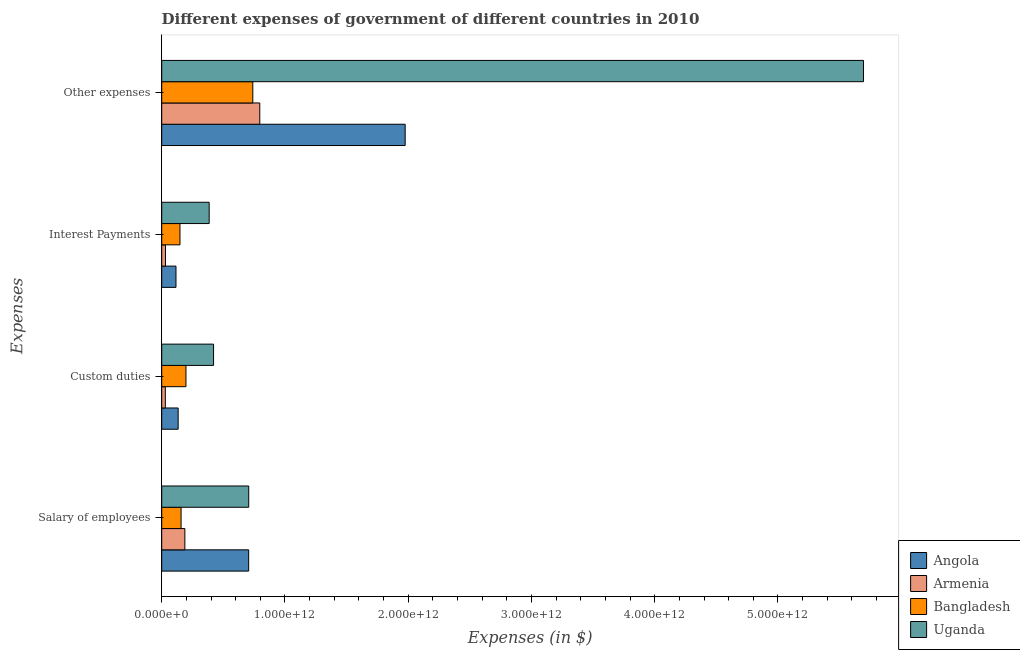How many different coloured bars are there?
Offer a terse response. 4. Are the number of bars on each tick of the Y-axis equal?
Your response must be concise. Yes. How many bars are there on the 3rd tick from the top?
Your answer should be compact. 4. How many bars are there on the 1st tick from the bottom?
Offer a very short reply. 4. What is the label of the 1st group of bars from the top?
Provide a short and direct response. Other expenses. What is the amount spent on custom duties in Angola?
Make the answer very short. 1.33e+11. Across all countries, what is the maximum amount spent on salary of employees?
Provide a short and direct response. 7.06e+11. Across all countries, what is the minimum amount spent on custom duties?
Your response must be concise. 2.94e+1. In which country was the amount spent on custom duties maximum?
Give a very brief answer. Uganda. In which country was the amount spent on custom duties minimum?
Ensure brevity in your answer.  Armenia. What is the total amount spent on other expenses in the graph?
Your answer should be compact. 9.20e+12. What is the difference between the amount spent on salary of employees in Angola and that in Uganda?
Your answer should be compact. -5.06e+08. What is the difference between the amount spent on salary of employees in Angola and the amount spent on other expenses in Bangladesh?
Provide a succinct answer. -3.34e+1. What is the average amount spent on salary of employees per country?
Keep it short and to the point. 4.39e+11. What is the difference between the amount spent on custom duties and amount spent on other expenses in Uganda?
Offer a terse response. -5.27e+12. What is the ratio of the amount spent on salary of employees in Bangladesh to that in Armenia?
Give a very brief answer. 0.84. Is the difference between the amount spent on interest payments in Bangladesh and Angola greater than the difference between the amount spent on custom duties in Bangladesh and Angola?
Provide a short and direct response. No. What is the difference between the highest and the second highest amount spent on custom duties?
Provide a short and direct response. 2.24e+11. What is the difference between the highest and the lowest amount spent on custom duties?
Offer a terse response. 3.91e+11. In how many countries, is the amount spent on custom duties greater than the average amount spent on custom duties taken over all countries?
Your answer should be very brief. 2. Is it the case that in every country, the sum of the amount spent on other expenses and amount spent on salary of employees is greater than the sum of amount spent on custom duties and amount spent on interest payments?
Provide a short and direct response. Yes. What does the 3rd bar from the top in Other expenses represents?
Offer a terse response. Armenia. What does the 4th bar from the bottom in Custom duties represents?
Provide a short and direct response. Uganda. Are all the bars in the graph horizontal?
Your answer should be compact. Yes. How many countries are there in the graph?
Provide a succinct answer. 4. What is the difference between two consecutive major ticks on the X-axis?
Offer a very short reply. 1.00e+12. Are the values on the major ticks of X-axis written in scientific E-notation?
Offer a terse response. Yes. Does the graph contain grids?
Your response must be concise. No. Where does the legend appear in the graph?
Your answer should be very brief. Bottom right. How are the legend labels stacked?
Provide a short and direct response. Vertical. What is the title of the graph?
Offer a terse response. Different expenses of government of different countries in 2010. What is the label or title of the X-axis?
Your answer should be very brief. Expenses (in $). What is the label or title of the Y-axis?
Provide a short and direct response. Expenses. What is the Expenses (in $) in Angola in Salary of employees?
Your answer should be compact. 7.06e+11. What is the Expenses (in $) in Armenia in Salary of employees?
Offer a very short reply. 1.88e+11. What is the Expenses (in $) in Bangladesh in Salary of employees?
Keep it short and to the point. 1.57e+11. What is the Expenses (in $) in Uganda in Salary of employees?
Keep it short and to the point. 7.06e+11. What is the Expenses (in $) in Angola in Custom duties?
Give a very brief answer. 1.33e+11. What is the Expenses (in $) of Armenia in Custom duties?
Your answer should be very brief. 2.94e+1. What is the Expenses (in $) in Bangladesh in Custom duties?
Keep it short and to the point. 1.97e+11. What is the Expenses (in $) in Uganda in Custom duties?
Your response must be concise. 4.21e+11. What is the Expenses (in $) in Angola in Interest Payments?
Ensure brevity in your answer.  1.16e+11. What is the Expenses (in $) in Armenia in Interest Payments?
Offer a very short reply. 3.04e+1. What is the Expenses (in $) of Bangladesh in Interest Payments?
Provide a short and direct response. 1.48e+11. What is the Expenses (in $) of Uganda in Interest Payments?
Your answer should be very brief. 3.85e+11. What is the Expenses (in $) in Angola in Other expenses?
Ensure brevity in your answer.  1.98e+12. What is the Expenses (in $) in Armenia in Other expenses?
Make the answer very short. 7.96e+11. What is the Expenses (in $) of Bangladesh in Other expenses?
Your response must be concise. 7.39e+11. What is the Expenses (in $) in Uganda in Other expenses?
Offer a terse response. 5.69e+12. Across all Expenses, what is the maximum Expenses (in $) of Angola?
Offer a terse response. 1.98e+12. Across all Expenses, what is the maximum Expenses (in $) in Armenia?
Provide a succinct answer. 7.96e+11. Across all Expenses, what is the maximum Expenses (in $) in Bangladesh?
Provide a succinct answer. 7.39e+11. Across all Expenses, what is the maximum Expenses (in $) of Uganda?
Offer a very short reply. 5.69e+12. Across all Expenses, what is the minimum Expenses (in $) of Angola?
Provide a short and direct response. 1.16e+11. Across all Expenses, what is the minimum Expenses (in $) in Armenia?
Provide a succinct answer. 2.94e+1. Across all Expenses, what is the minimum Expenses (in $) in Bangladesh?
Offer a very short reply. 1.48e+11. Across all Expenses, what is the minimum Expenses (in $) in Uganda?
Your answer should be very brief. 3.85e+11. What is the total Expenses (in $) of Angola in the graph?
Give a very brief answer. 2.93e+12. What is the total Expenses (in $) in Armenia in the graph?
Offer a terse response. 1.04e+12. What is the total Expenses (in $) in Bangladesh in the graph?
Give a very brief answer. 1.24e+12. What is the total Expenses (in $) of Uganda in the graph?
Offer a terse response. 7.21e+12. What is the difference between the Expenses (in $) of Angola in Salary of employees and that in Custom duties?
Provide a succinct answer. 5.72e+11. What is the difference between the Expenses (in $) in Armenia in Salary of employees and that in Custom duties?
Offer a terse response. 1.58e+11. What is the difference between the Expenses (in $) in Bangladesh in Salary of employees and that in Custom duties?
Keep it short and to the point. -3.95e+1. What is the difference between the Expenses (in $) in Uganda in Salary of employees and that in Custom duties?
Offer a very short reply. 2.85e+11. What is the difference between the Expenses (in $) in Angola in Salary of employees and that in Interest Payments?
Offer a very short reply. 5.90e+11. What is the difference between the Expenses (in $) in Armenia in Salary of employees and that in Interest Payments?
Make the answer very short. 1.57e+11. What is the difference between the Expenses (in $) in Bangladesh in Salary of employees and that in Interest Payments?
Give a very brief answer. 8.98e+09. What is the difference between the Expenses (in $) in Uganda in Salary of employees and that in Interest Payments?
Provide a succinct answer. 3.21e+11. What is the difference between the Expenses (in $) of Angola in Salary of employees and that in Other expenses?
Your response must be concise. -1.27e+12. What is the difference between the Expenses (in $) in Armenia in Salary of employees and that in Other expenses?
Ensure brevity in your answer.  -6.08e+11. What is the difference between the Expenses (in $) of Bangladesh in Salary of employees and that in Other expenses?
Ensure brevity in your answer.  -5.82e+11. What is the difference between the Expenses (in $) of Uganda in Salary of employees and that in Other expenses?
Provide a short and direct response. -4.99e+12. What is the difference between the Expenses (in $) of Angola in Custom duties and that in Interest Payments?
Offer a very short reply. 1.76e+1. What is the difference between the Expenses (in $) of Armenia in Custom duties and that in Interest Payments?
Give a very brief answer. -1.07e+09. What is the difference between the Expenses (in $) of Bangladesh in Custom duties and that in Interest Payments?
Provide a succinct answer. 4.85e+1. What is the difference between the Expenses (in $) of Uganda in Custom duties and that in Interest Payments?
Your response must be concise. 3.56e+1. What is the difference between the Expenses (in $) in Angola in Custom duties and that in Other expenses?
Make the answer very short. -1.84e+12. What is the difference between the Expenses (in $) in Armenia in Custom duties and that in Other expenses?
Ensure brevity in your answer.  -7.66e+11. What is the difference between the Expenses (in $) of Bangladesh in Custom duties and that in Other expenses?
Make the answer very short. -5.42e+11. What is the difference between the Expenses (in $) in Uganda in Custom duties and that in Other expenses?
Ensure brevity in your answer.  -5.27e+12. What is the difference between the Expenses (in $) of Angola in Interest Payments and that in Other expenses?
Provide a short and direct response. -1.86e+12. What is the difference between the Expenses (in $) of Armenia in Interest Payments and that in Other expenses?
Your answer should be very brief. -7.65e+11. What is the difference between the Expenses (in $) in Bangladesh in Interest Payments and that in Other expenses?
Offer a terse response. -5.91e+11. What is the difference between the Expenses (in $) of Uganda in Interest Payments and that in Other expenses?
Your answer should be compact. -5.31e+12. What is the difference between the Expenses (in $) of Angola in Salary of employees and the Expenses (in $) of Armenia in Custom duties?
Your response must be concise. 6.76e+11. What is the difference between the Expenses (in $) in Angola in Salary of employees and the Expenses (in $) in Bangladesh in Custom duties?
Offer a terse response. 5.09e+11. What is the difference between the Expenses (in $) in Angola in Salary of employees and the Expenses (in $) in Uganda in Custom duties?
Make the answer very short. 2.85e+11. What is the difference between the Expenses (in $) in Armenia in Salary of employees and the Expenses (in $) in Bangladesh in Custom duties?
Keep it short and to the point. -8.88e+09. What is the difference between the Expenses (in $) in Armenia in Salary of employees and the Expenses (in $) in Uganda in Custom duties?
Offer a terse response. -2.33e+11. What is the difference between the Expenses (in $) in Bangladesh in Salary of employees and the Expenses (in $) in Uganda in Custom duties?
Provide a short and direct response. -2.64e+11. What is the difference between the Expenses (in $) of Angola in Salary of employees and the Expenses (in $) of Armenia in Interest Payments?
Provide a succinct answer. 6.75e+11. What is the difference between the Expenses (in $) in Angola in Salary of employees and the Expenses (in $) in Bangladesh in Interest Payments?
Your response must be concise. 5.57e+11. What is the difference between the Expenses (in $) of Angola in Salary of employees and the Expenses (in $) of Uganda in Interest Payments?
Provide a short and direct response. 3.20e+11. What is the difference between the Expenses (in $) in Armenia in Salary of employees and the Expenses (in $) in Bangladesh in Interest Payments?
Offer a terse response. 3.96e+1. What is the difference between the Expenses (in $) of Armenia in Salary of employees and the Expenses (in $) of Uganda in Interest Payments?
Give a very brief answer. -1.97e+11. What is the difference between the Expenses (in $) of Bangladesh in Salary of employees and the Expenses (in $) of Uganda in Interest Payments?
Offer a very short reply. -2.28e+11. What is the difference between the Expenses (in $) of Angola in Salary of employees and the Expenses (in $) of Armenia in Other expenses?
Your answer should be compact. -9.02e+1. What is the difference between the Expenses (in $) of Angola in Salary of employees and the Expenses (in $) of Bangladesh in Other expenses?
Your response must be concise. -3.34e+1. What is the difference between the Expenses (in $) in Angola in Salary of employees and the Expenses (in $) in Uganda in Other expenses?
Ensure brevity in your answer.  -4.99e+12. What is the difference between the Expenses (in $) in Armenia in Salary of employees and the Expenses (in $) in Bangladesh in Other expenses?
Provide a succinct answer. -5.51e+11. What is the difference between the Expenses (in $) in Armenia in Salary of employees and the Expenses (in $) in Uganda in Other expenses?
Provide a short and direct response. -5.51e+12. What is the difference between the Expenses (in $) in Bangladesh in Salary of employees and the Expenses (in $) in Uganda in Other expenses?
Provide a succinct answer. -5.54e+12. What is the difference between the Expenses (in $) of Angola in Custom duties and the Expenses (in $) of Armenia in Interest Payments?
Your answer should be compact. 1.03e+11. What is the difference between the Expenses (in $) in Angola in Custom duties and the Expenses (in $) in Bangladesh in Interest Payments?
Ensure brevity in your answer.  -1.47e+1. What is the difference between the Expenses (in $) of Angola in Custom duties and the Expenses (in $) of Uganda in Interest Payments?
Your response must be concise. -2.52e+11. What is the difference between the Expenses (in $) of Armenia in Custom duties and the Expenses (in $) of Bangladesh in Interest Payments?
Give a very brief answer. -1.19e+11. What is the difference between the Expenses (in $) in Armenia in Custom duties and the Expenses (in $) in Uganda in Interest Payments?
Your response must be concise. -3.56e+11. What is the difference between the Expenses (in $) of Bangladesh in Custom duties and the Expenses (in $) of Uganda in Interest Payments?
Give a very brief answer. -1.88e+11. What is the difference between the Expenses (in $) of Angola in Custom duties and the Expenses (in $) of Armenia in Other expenses?
Ensure brevity in your answer.  -6.62e+11. What is the difference between the Expenses (in $) of Angola in Custom duties and the Expenses (in $) of Bangladesh in Other expenses?
Your answer should be compact. -6.06e+11. What is the difference between the Expenses (in $) of Angola in Custom duties and the Expenses (in $) of Uganda in Other expenses?
Provide a short and direct response. -5.56e+12. What is the difference between the Expenses (in $) of Armenia in Custom duties and the Expenses (in $) of Bangladesh in Other expenses?
Ensure brevity in your answer.  -7.10e+11. What is the difference between the Expenses (in $) in Armenia in Custom duties and the Expenses (in $) in Uganda in Other expenses?
Make the answer very short. -5.66e+12. What is the difference between the Expenses (in $) in Bangladesh in Custom duties and the Expenses (in $) in Uganda in Other expenses?
Keep it short and to the point. -5.50e+12. What is the difference between the Expenses (in $) in Angola in Interest Payments and the Expenses (in $) in Armenia in Other expenses?
Offer a very short reply. -6.80e+11. What is the difference between the Expenses (in $) of Angola in Interest Payments and the Expenses (in $) of Bangladesh in Other expenses?
Provide a succinct answer. -6.23e+11. What is the difference between the Expenses (in $) in Angola in Interest Payments and the Expenses (in $) in Uganda in Other expenses?
Your answer should be compact. -5.58e+12. What is the difference between the Expenses (in $) of Armenia in Interest Payments and the Expenses (in $) of Bangladesh in Other expenses?
Keep it short and to the point. -7.09e+11. What is the difference between the Expenses (in $) of Armenia in Interest Payments and the Expenses (in $) of Uganda in Other expenses?
Your answer should be very brief. -5.66e+12. What is the difference between the Expenses (in $) of Bangladesh in Interest Payments and the Expenses (in $) of Uganda in Other expenses?
Offer a very short reply. -5.55e+12. What is the average Expenses (in $) of Angola per Expenses?
Provide a succinct answer. 7.33e+11. What is the average Expenses (in $) of Armenia per Expenses?
Give a very brief answer. 2.61e+11. What is the average Expenses (in $) of Bangladesh per Expenses?
Give a very brief answer. 3.10e+11. What is the average Expenses (in $) in Uganda per Expenses?
Keep it short and to the point. 1.80e+12. What is the difference between the Expenses (in $) in Angola and Expenses (in $) in Armenia in Salary of employees?
Make the answer very short. 5.18e+11. What is the difference between the Expenses (in $) in Angola and Expenses (in $) in Bangladesh in Salary of employees?
Provide a short and direct response. 5.48e+11. What is the difference between the Expenses (in $) in Angola and Expenses (in $) in Uganda in Salary of employees?
Ensure brevity in your answer.  -5.06e+08. What is the difference between the Expenses (in $) in Armenia and Expenses (in $) in Bangladesh in Salary of employees?
Your answer should be compact. 3.06e+1. What is the difference between the Expenses (in $) in Armenia and Expenses (in $) in Uganda in Salary of employees?
Keep it short and to the point. -5.18e+11. What is the difference between the Expenses (in $) in Bangladesh and Expenses (in $) in Uganda in Salary of employees?
Offer a very short reply. -5.49e+11. What is the difference between the Expenses (in $) in Angola and Expenses (in $) in Armenia in Custom duties?
Give a very brief answer. 1.04e+11. What is the difference between the Expenses (in $) in Angola and Expenses (in $) in Bangladesh in Custom duties?
Offer a very short reply. -6.32e+1. What is the difference between the Expenses (in $) in Angola and Expenses (in $) in Uganda in Custom duties?
Your response must be concise. -2.87e+11. What is the difference between the Expenses (in $) of Armenia and Expenses (in $) of Bangladesh in Custom duties?
Your answer should be compact. -1.67e+11. What is the difference between the Expenses (in $) of Armenia and Expenses (in $) of Uganda in Custom duties?
Provide a succinct answer. -3.91e+11. What is the difference between the Expenses (in $) in Bangladesh and Expenses (in $) in Uganda in Custom duties?
Give a very brief answer. -2.24e+11. What is the difference between the Expenses (in $) in Angola and Expenses (in $) in Armenia in Interest Payments?
Offer a terse response. 8.54e+1. What is the difference between the Expenses (in $) of Angola and Expenses (in $) of Bangladesh in Interest Payments?
Your answer should be very brief. -3.23e+1. What is the difference between the Expenses (in $) of Angola and Expenses (in $) of Uganda in Interest Payments?
Offer a terse response. -2.69e+11. What is the difference between the Expenses (in $) in Armenia and Expenses (in $) in Bangladesh in Interest Payments?
Your answer should be compact. -1.18e+11. What is the difference between the Expenses (in $) in Armenia and Expenses (in $) in Uganda in Interest Payments?
Provide a succinct answer. -3.55e+11. What is the difference between the Expenses (in $) in Bangladesh and Expenses (in $) in Uganda in Interest Payments?
Offer a very short reply. -2.37e+11. What is the difference between the Expenses (in $) of Angola and Expenses (in $) of Armenia in Other expenses?
Provide a short and direct response. 1.18e+12. What is the difference between the Expenses (in $) of Angola and Expenses (in $) of Bangladesh in Other expenses?
Give a very brief answer. 1.24e+12. What is the difference between the Expenses (in $) in Angola and Expenses (in $) in Uganda in Other expenses?
Make the answer very short. -3.72e+12. What is the difference between the Expenses (in $) of Armenia and Expenses (in $) of Bangladesh in Other expenses?
Give a very brief answer. 5.67e+1. What is the difference between the Expenses (in $) in Armenia and Expenses (in $) in Uganda in Other expenses?
Offer a terse response. -4.90e+12. What is the difference between the Expenses (in $) of Bangladesh and Expenses (in $) of Uganda in Other expenses?
Ensure brevity in your answer.  -4.96e+12. What is the ratio of the Expenses (in $) of Angola in Salary of employees to that in Custom duties?
Provide a succinct answer. 5.29. What is the ratio of the Expenses (in $) in Armenia in Salary of employees to that in Custom duties?
Provide a succinct answer. 6.39. What is the ratio of the Expenses (in $) in Bangladesh in Salary of employees to that in Custom duties?
Make the answer very short. 0.8. What is the ratio of the Expenses (in $) in Uganda in Salary of employees to that in Custom duties?
Offer a very short reply. 1.68. What is the ratio of the Expenses (in $) of Angola in Salary of employees to that in Interest Payments?
Offer a terse response. 6.09. What is the ratio of the Expenses (in $) in Armenia in Salary of employees to that in Interest Payments?
Keep it short and to the point. 6.17. What is the ratio of the Expenses (in $) of Bangladesh in Salary of employees to that in Interest Payments?
Keep it short and to the point. 1.06. What is the ratio of the Expenses (in $) of Uganda in Salary of employees to that in Interest Payments?
Provide a short and direct response. 1.83. What is the ratio of the Expenses (in $) in Angola in Salary of employees to that in Other expenses?
Offer a very short reply. 0.36. What is the ratio of the Expenses (in $) in Armenia in Salary of employees to that in Other expenses?
Provide a succinct answer. 0.24. What is the ratio of the Expenses (in $) of Bangladesh in Salary of employees to that in Other expenses?
Provide a succinct answer. 0.21. What is the ratio of the Expenses (in $) in Uganda in Salary of employees to that in Other expenses?
Offer a very short reply. 0.12. What is the ratio of the Expenses (in $) of Angola in Custom duties to that in Interest Payments?
Your response must be concise. 1.15. What is the ratio of the Expenses (in $) of Armenia in Custom duties to that in Interest Payments?
Provide a succinct answer. 0.96. What is the ratio of the Expenses (in $) of Bangladesh in Custom duties to that in Interest Payments?
Keep it short and to the point. 1.33. What is the ratio of the Expenses (in $) in Uganda in Custom duties to that in Interest Payments?
Provide a short and direct response. 1.09. What is the ratio of the Expenses (in $) in Angola in Custom duties to that in Other expenses?
Your response must be concise. 0.07. What is the ratio of the Expenses (in $) of Armenia in Custom duties to that in Other expenses?
Offer a very short reply. 0.04. What is the ratio of the Expenses (in $) of Bangladesh in Custom duties to that in Other expenses?
Provide a succinct answer. 0.27. What is the ratio of the Expenses (in $) of Uganda in Custom duties to that in Other expenses?
Keep it short and to the point. 0.07. What is the ratio of the Expenses (in $) of Angola in Interest Payments to that in Other expenses?
Ensure brevity in your answer.  0.06. What is the ratio of the Expenses (in $) of Armenia in Interest Payments to that in Other expenses?
Provide a short and direct response. 0.04. What is the ratio of the Expenses (in $) of Bangladesh in Interest Payments to that in Other expenses?
Your response must be concise. 0.2. What is the ratio of the Expenses (in $) of Uganda in Interest Payments to that in Other expenses?
Your answer should be very brief. 0.07. What is the difference between the highest and the second highest Expenses (in $) in Angola?
Provide a succinct answer. 1.27e+12. What is the difference between the highest and the second highest Expenses (in $) of Armenia?
Make the answer very short. 6.08e+11. What is the difference between the highest and the second highest Expenses (in $) of Bangladesh?
Ensure brevity in your answer.  5.42e+11. What is the difference between the highest and the second highest Expenses (in $) of Uganda?
Provide a succinct answer. 4.99e+12. What is the difference between the highest and the lowest Expenses (in $) in Angola?
Your response must be concise. 1.86e+12. What is the difference between the highest and the lowest Expenses (in $) of Armenia?
Your answer should be compact. 7.66e+11. What is the difference between the highest and the lowest Expenses (in $) in Bangladesh?
Ensure brevity in your answer.  5.91e+11. What is the difference between the highest and the lowest Expenses (in $) of Uganda?
Your answer should be very brief. 5.31e+12. 